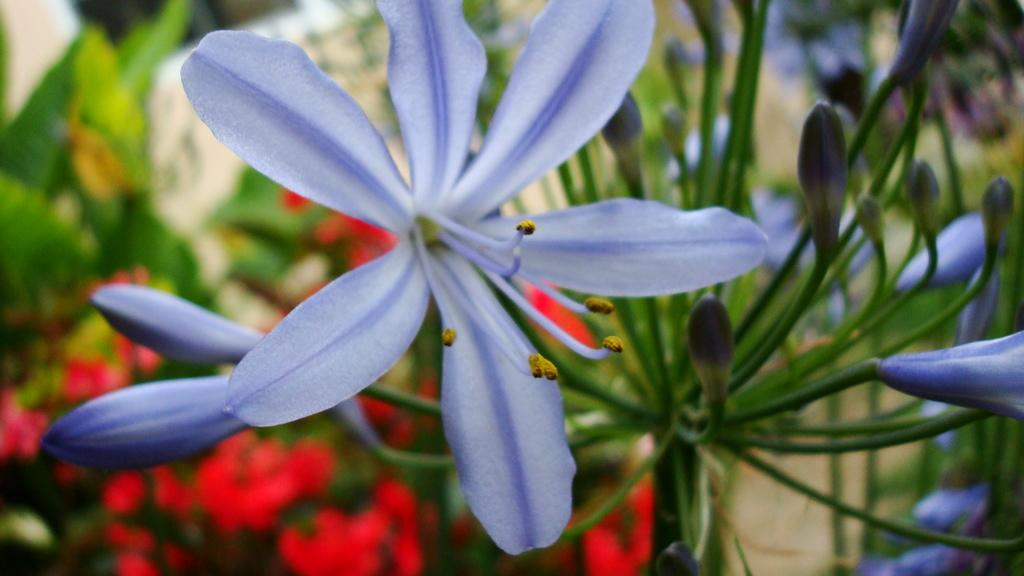What is located in the front of the image? There is a flower and buds in the front of the image. What type of vegetation can be seen in the background of the image? There are plants in the background of the image, including red color flowers. How does the background appear in the image? The background appears blurry. How does the station stretch its stomach in the image? There is no station or stomach present in the image; it features a flower, buds, and plants. 